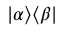<formula> <loc_0><loc_0><loc_500><loc_500>| \alpha \rangle \langle \beta |</formula> 